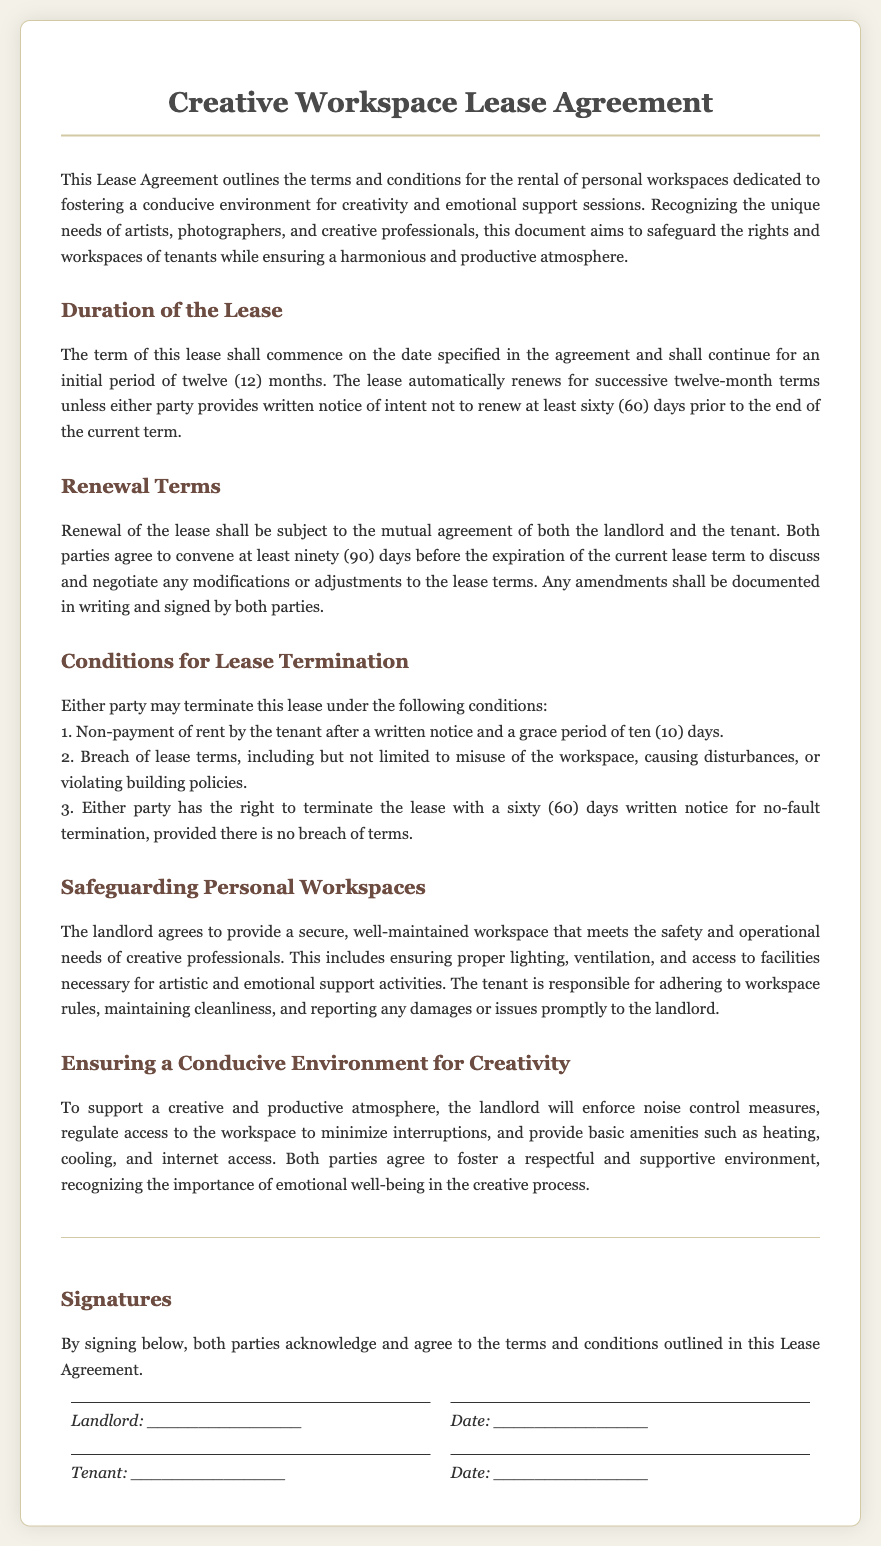What is the duration of the lease? The duration of the lease is specified as an initial period of twelve months.
Answer: twelve (12) months What is the notice period required for lease renewal? The notice period required for lease renewal is at least sixty days prior to the end of the current term.
Answer: sixty (60) days How long before the lease expiration should both parties meet to discuss renewal? Both parties should convene at least ninety days before the expiration of the current lease term.
Answer: ninety (90) days What is one reason a lease can be terminated? One reason for lease termination is non-payment of rent by the tenant after a written notice and a grace period.
Answer: Non-payment of rent What must the landlord provide in terms of the workspace? The landlord must provide a secure, well-maintained workspace that meets safety and operational needs.
Answer: secure, well-maintained workspace What is the tenant responsible for regarding the workspace? The tenant is responsible for adhering to workspace rules, maintaining cleanliness, and reporting any damages.
Answer: adhering to workspace rules How many days of written notice does either party need for no-fault termination? Either party must provide sixty days of written notice for a no-fault termination.
Answer: sixty (60) days What atmosphere does the landlord agree to foster for creativity? The landlord agrees to foster a respectful and supportive environment for creativity.
Answer: respectful and supportive environment 